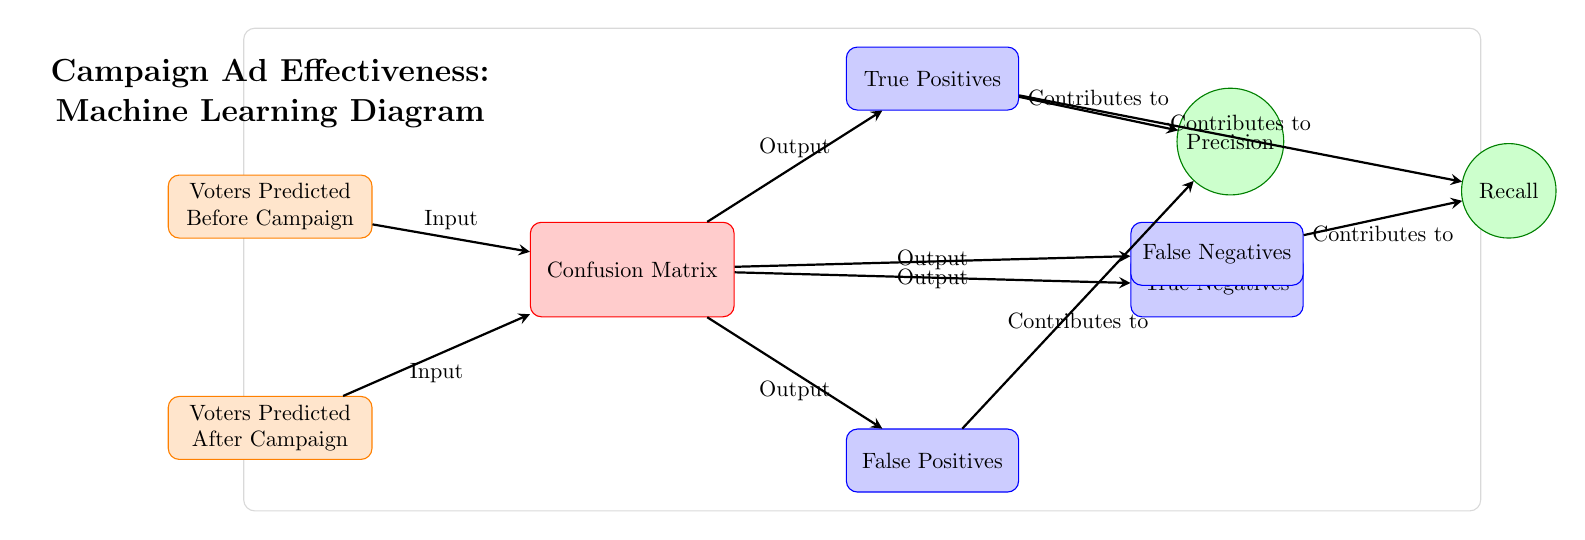What are the two inputs shown in the diagram? The diagram provides two distinct inputs labeled "Voters Predicted Before Campaign" and "Voters Predicted After Campaign." These indicate the voters' predictions prior to and following the campaign efforts.
Answer: Voters Predicted Before Campaign, Voters Predicted After Campaign How many outputs are there from the confusion matrix? The confusion matrix yields four outputs: True Positives, False Positives, True Negatives, and False Negatives. Thus, it has a total of four outputs derived from its analysis.
Answer: Four Which output contributes to precision? The outputs contributing to precision are True Positives and False Positives, as precision is calculated based on these values to determine the proportion of correct positive identifications.
Answer: True Positives, False Positives What is the relationship between True Negatives and False Positives? True Negatives and False Positives are positioned in the confusion matrix, with True Negatives above and False Positives directly below it. This indicates they are both outputs derived from the confusion matrix concerning voter predictions.
Answer: True Negatives above False Positives Calculate Recall based on True Positives and False Negatives. Recall is determined by the relationship between True Positives and False Negatives, as indicated in the diagram. Specifically, it is the proportion of actual positive cases that were identified correctly, thus linking them directly in the context of the confusion matrix.
Answer: True Positives, False Negatives What does the confusion matrix illustrate? The confusion matrix illustrates the effectiveness of the campaign ad by comparing the predicted voter sway before and after the campaign, thereby showcasing the outcomes categorized as true positives, false positives, true negatives, and false negatives.
Answer: Effectiveness of campaign ad What type of diagram is this? This is a Machine Learning Diagram specifically representing a Confusion Matrix, used to evaluate the effectiveness of campaign advertisements on voter predictions.
Answer: Machine Learning Diagram What contributes to recall according to the diagram? Recall is determined by the True Positives and False Negatives. These values are essential in assessing how well the campaign identified actual sway among the voters by capturing positive responses accurately.
Answer: True Positives, False Negatives 